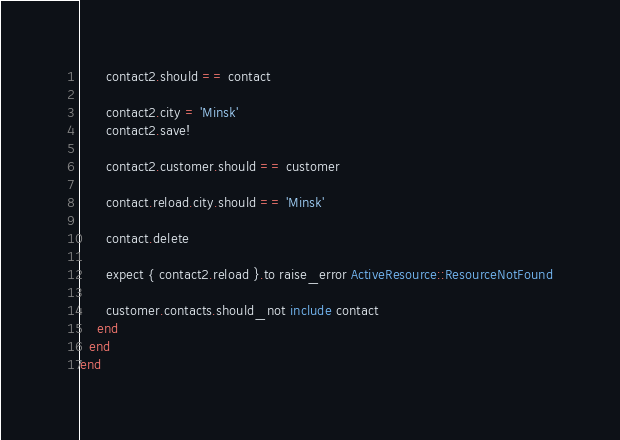Convert code to text. <code><loc_0><loc_0><loc_500><loc_500><_Ruby_>      contact2.should == contact

      contact2.city = 'Minsk'
      contact2.save!

      contact2.customer.should == customer

      contact.reload.city.should == 'Minsk'

      contact.delete

      expect { contact2.reload }.to raise_error ActiveResource::ResourceNotFound

      customer.contacts.should_not include contact
    end
  end
end</code> 